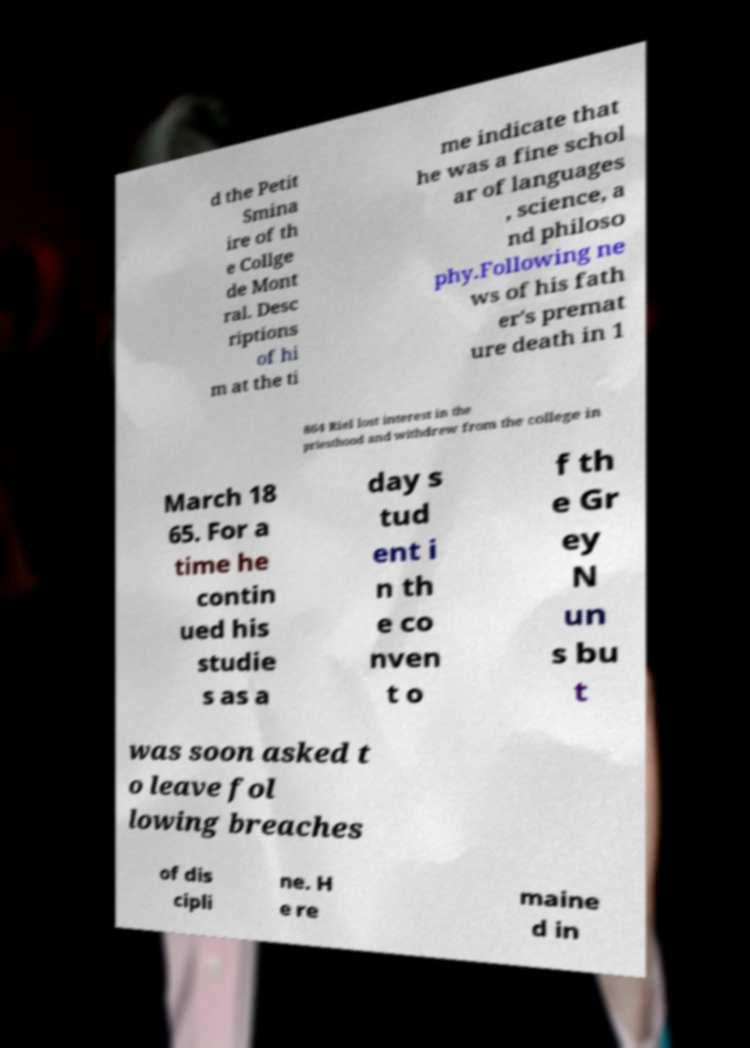Could you assist in decoding the text presented in this image and type it out clearly? d the Petit Smina ire of th e Collge de Mont ral. Desc riptions of hi m at the ti me indicate that he was a fine schol ar of languages , science, a nd philoso phy.Following ne ws of his fath er's premat ure death in 1 864 Riel lost interest in the priesthood and withdrew from the college in March 18 65. For a time he contin ued his studie s as a day s tud ent i n th e co nven t o f th e Gr ey N un s bu t was soon asked t o leave fol lowing breaches of dis cipli ne. H e re maine d in 